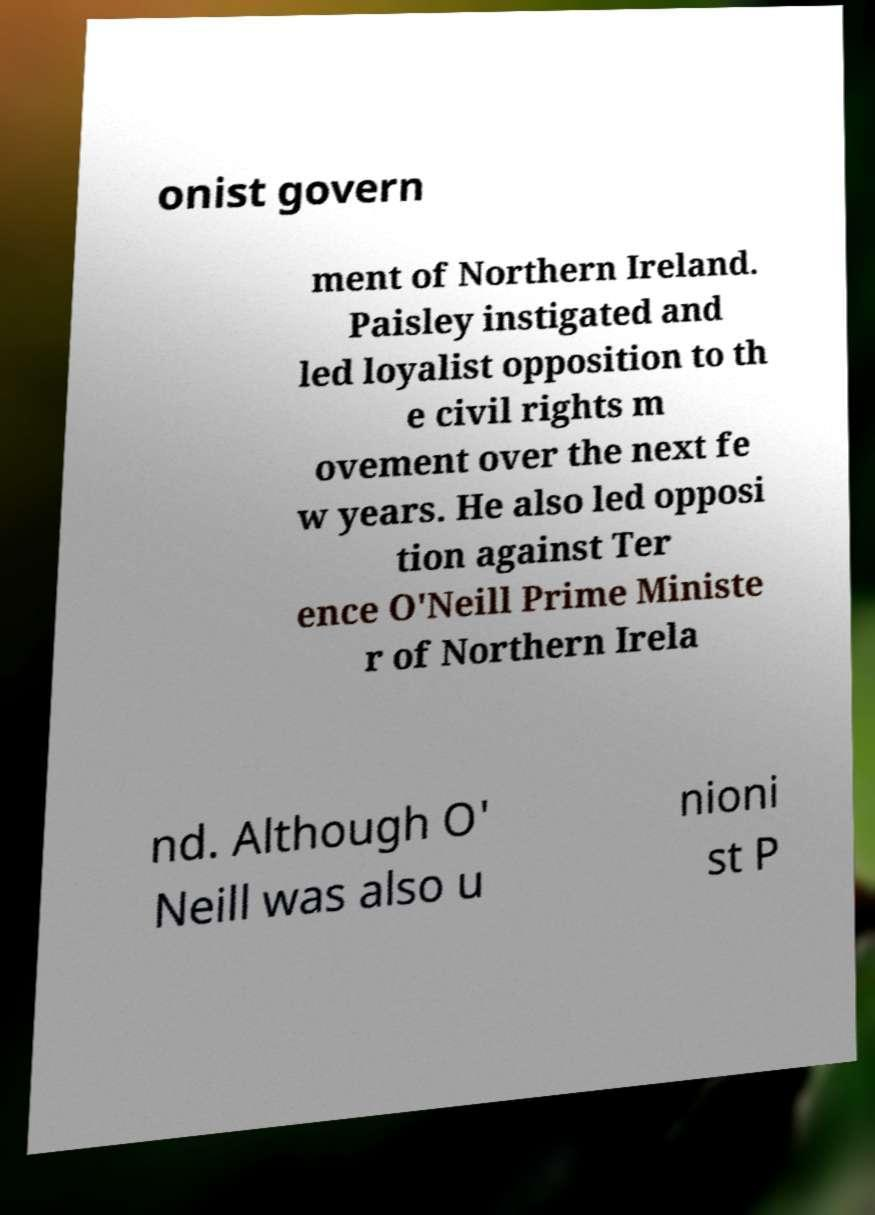Please read and relay the text visible in this image. What does it say? onist govern ment of Northern Ireland. Paisley instigated and led loyalist opposition to th e civil rights m ovement over the next fe w years. He also led opposi tion against Ter ence O'Neill Prime Ministe r of Northern Irela nd. Although O' Neill was also u nioni st P 